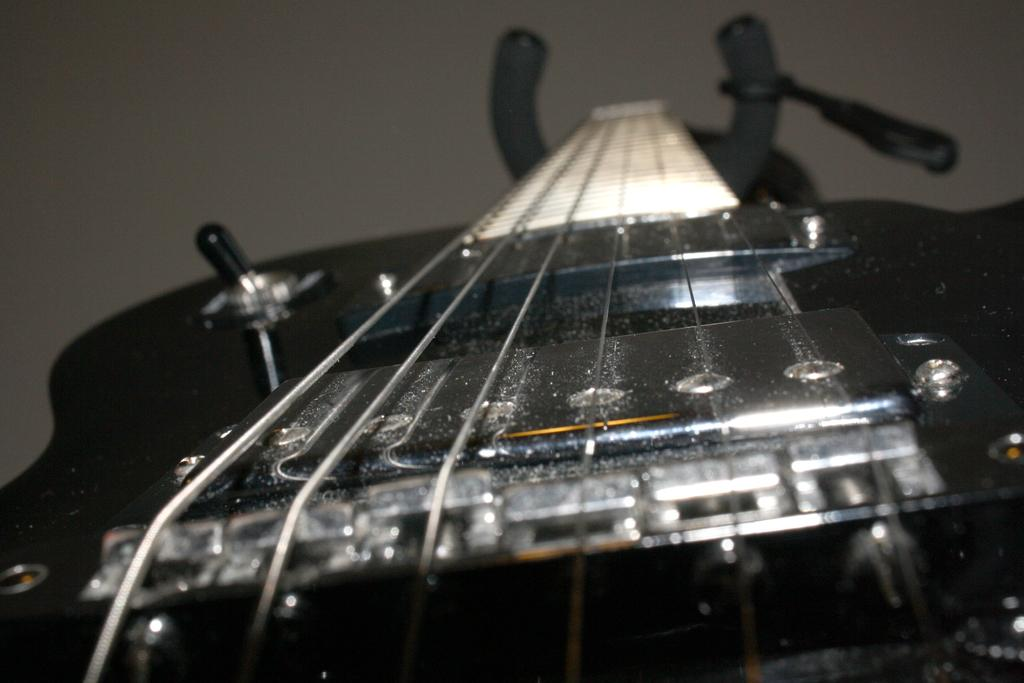What is the main subject of the zoomed in picture? The main subject of the zoomed in picture is a guitar. What is the color of the guitar in the image? The guitar is black in color. What can be seen in the background of the image? There is a wall visible in the background of the image. Can you tell me how many snails are crawling on the guitar in the image? There are no snails present on the guitar in the image. What stage of development is the guitar in the image? The image is a picture of a guitar, and guitars do not have a development stage like living organisms. 